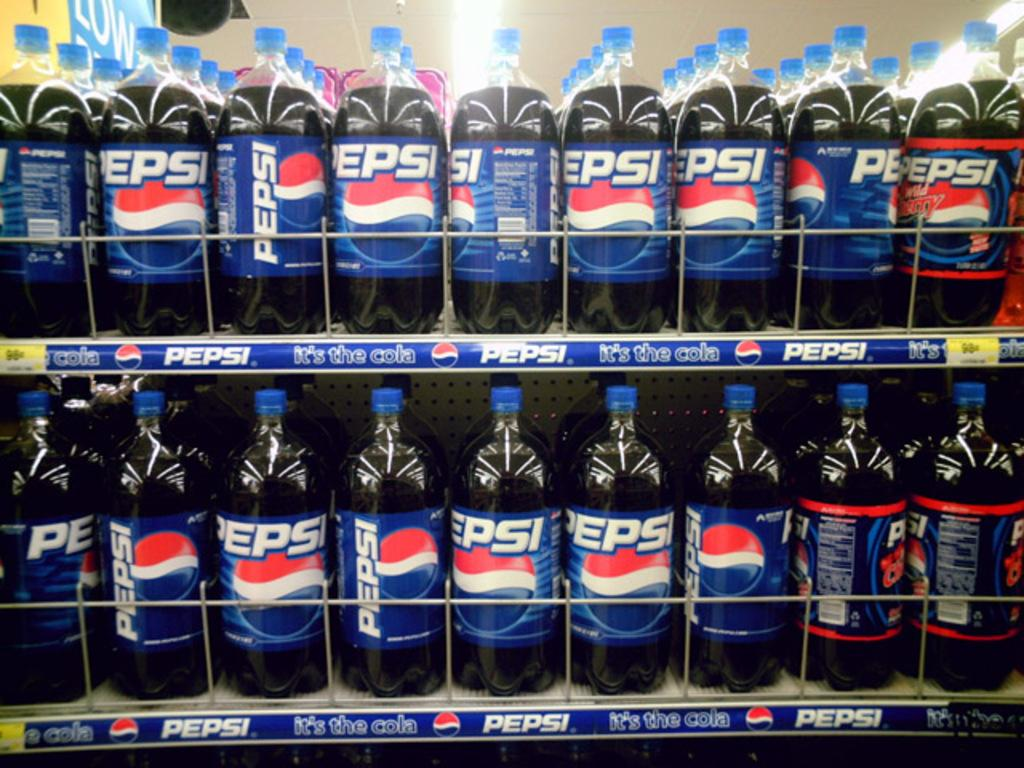<image>
Write a terse but informative summary of the picture. two shelves in a store full of pepsi bottles 